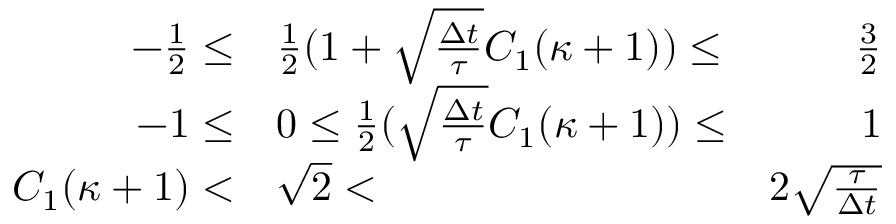Convert formula to latex. <formula><loc_0><loc_0><loc_500><loc_500>\begin{array} { r l r } { - \frac { 1 } { 2 } \leq } & { \frac { 1 } { 2 } ( 1 + \sqrt { \frac { \Delta t } { \tau } } C _ { 1 } ( \kappa + 1 ) ) \leq } & { \frac { 3 } { 2 } } \\ { - 1 \leq } & { 0 \leq \frac { 1 } { 2 } ( \sqrt { \frac { \Delta t } { \tau } } C _ { 1 } ( \kappa + 1 ) ) \leq } & { 1 } \\ { C _ { 1 } ( \kappa + 1 ) < } & { \sqrt { 2 } < } & { 2 \sqrt { \frac { \tau } { \Delta t } } } \end{array}</formula> 